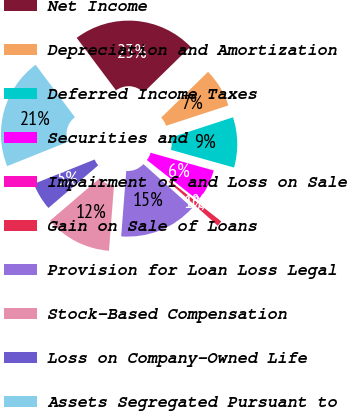Convert chart to OTSL. <chart><loc_0><loc_0><loc_500><loc_500><pie_chart><fcel>Net Income<fcel>Depreciation and Amortization<fcel>Deferred Income Taxes<fcel>Securities and<fcel>Impairment of and Loss on Sale<fcel>Gain on Sale of Loans<fcel>Provision for Loan Loss Legal<fcel>Stock-Based Compensation<fcel>Loss on Company-Owned Life<fcel>Assets Segregated Pursuant to<nl><fcel>22.92%<fcel>7.29%<fcel>9.38%<fcel>6.25%<fcel>0.0%<fcel>1.04%<fcel>14.58%<fcel>12.5%<fcel>5.21%<fcel>20.83%<nl></chart> 